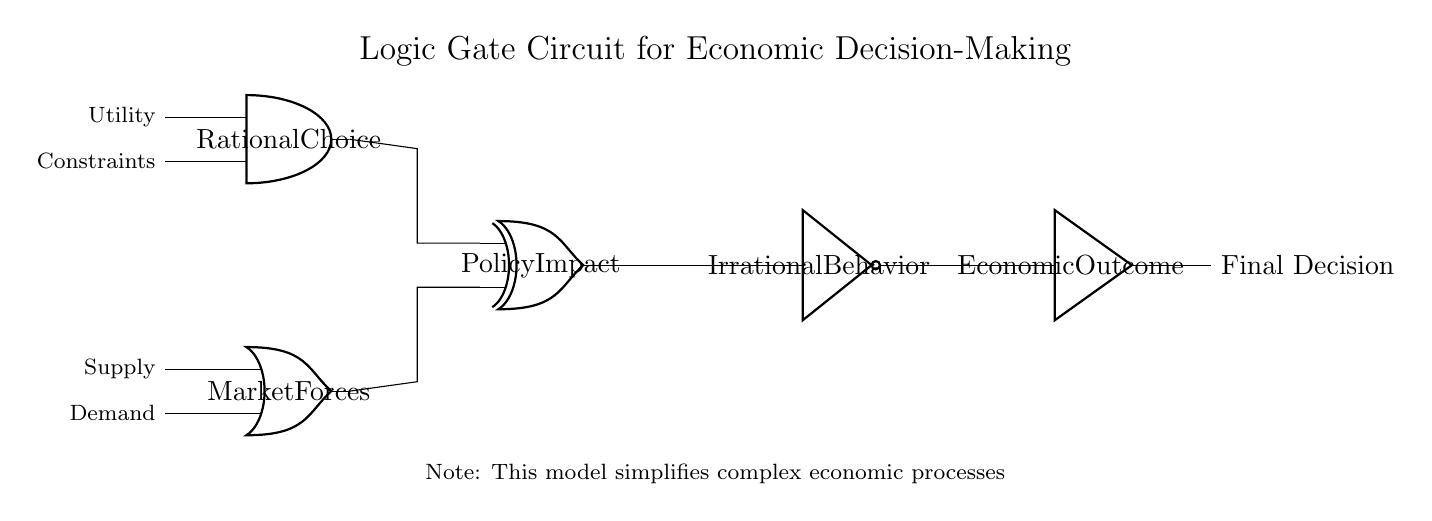What type of logic gate is used at the input of Rational Choice? The input of Rational Choice is an AND gate, which indicates a requirement for both Utility and Constraints to be satisfied.
Answer: AND gate What are the two inputs for the Market Forces gate? The Market Forces gate is an OR gate that accepts Supply and Demand as its two inputs, indicating that any of these factors can influence market forces independently.
Answer: Supply and Demand What is the output of the Policy Impact gate? The output of the Policy Impact gate is the XOR gate's output, which suggests that it produces a result based on the exclusivity of its input conditions—either Rational Choice or Market Forces, but not both together.
Answer: XOR output Which component represents irrational behavior? The Not gate represents irrational behavior, indicating a negation of the output from the Policy Impact gate, thus impacting the Economic Outcome.
Answer: Not gate How does the Economic Outcome gate affect final decisions? The Economic Outcome gate acts as a buffer, meaning it transmits the input without change, directly affecting the final decision by providing the negative state of the Policy Impact.
Answer: It transmits the input directly What does the circuit model suggest about economic decision-making? The circuit suggests that economic decision-making is influenced by a combination of rational choices, market forces, and potential irrational behaviors, forming a complex process modeled with logic gates.
Answer: Influenced by rational choices, market forces, and irrational behaviors 